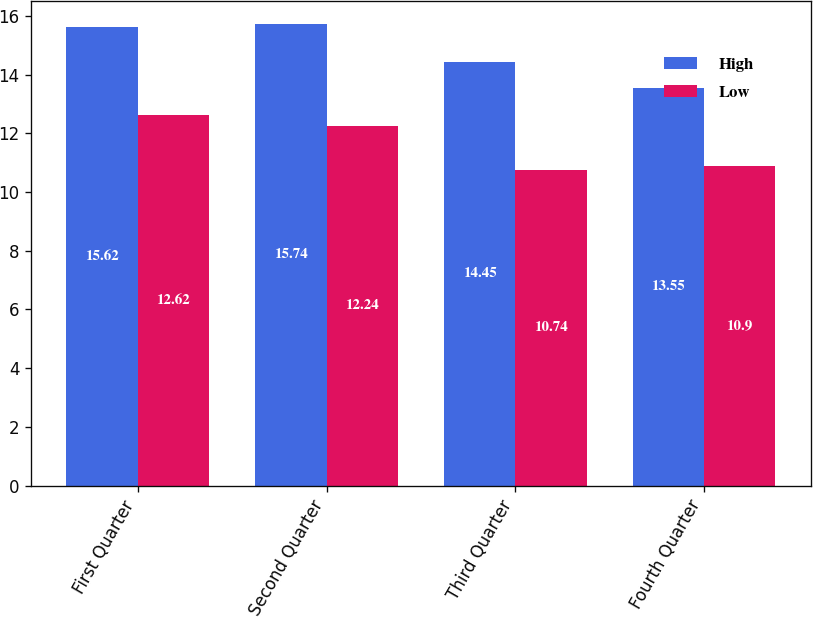Convert chart to OTSL. <chart><loc_0><loc_0><loc_500><loc_500><stacked_bar_chart><ecel><fcel>First Quarter<fcel>Second Quarter<fcel>Third Quarter<fcel>Fourth Quarter<nl><fcel>High<fcel>15.62<fcel>15.74<fcel>14.45<fcel>13.55<nl><fcel>Low<fcel>12.62<fcel>12.24<fcel>10.74<fcel>10.9<nl></chart> 